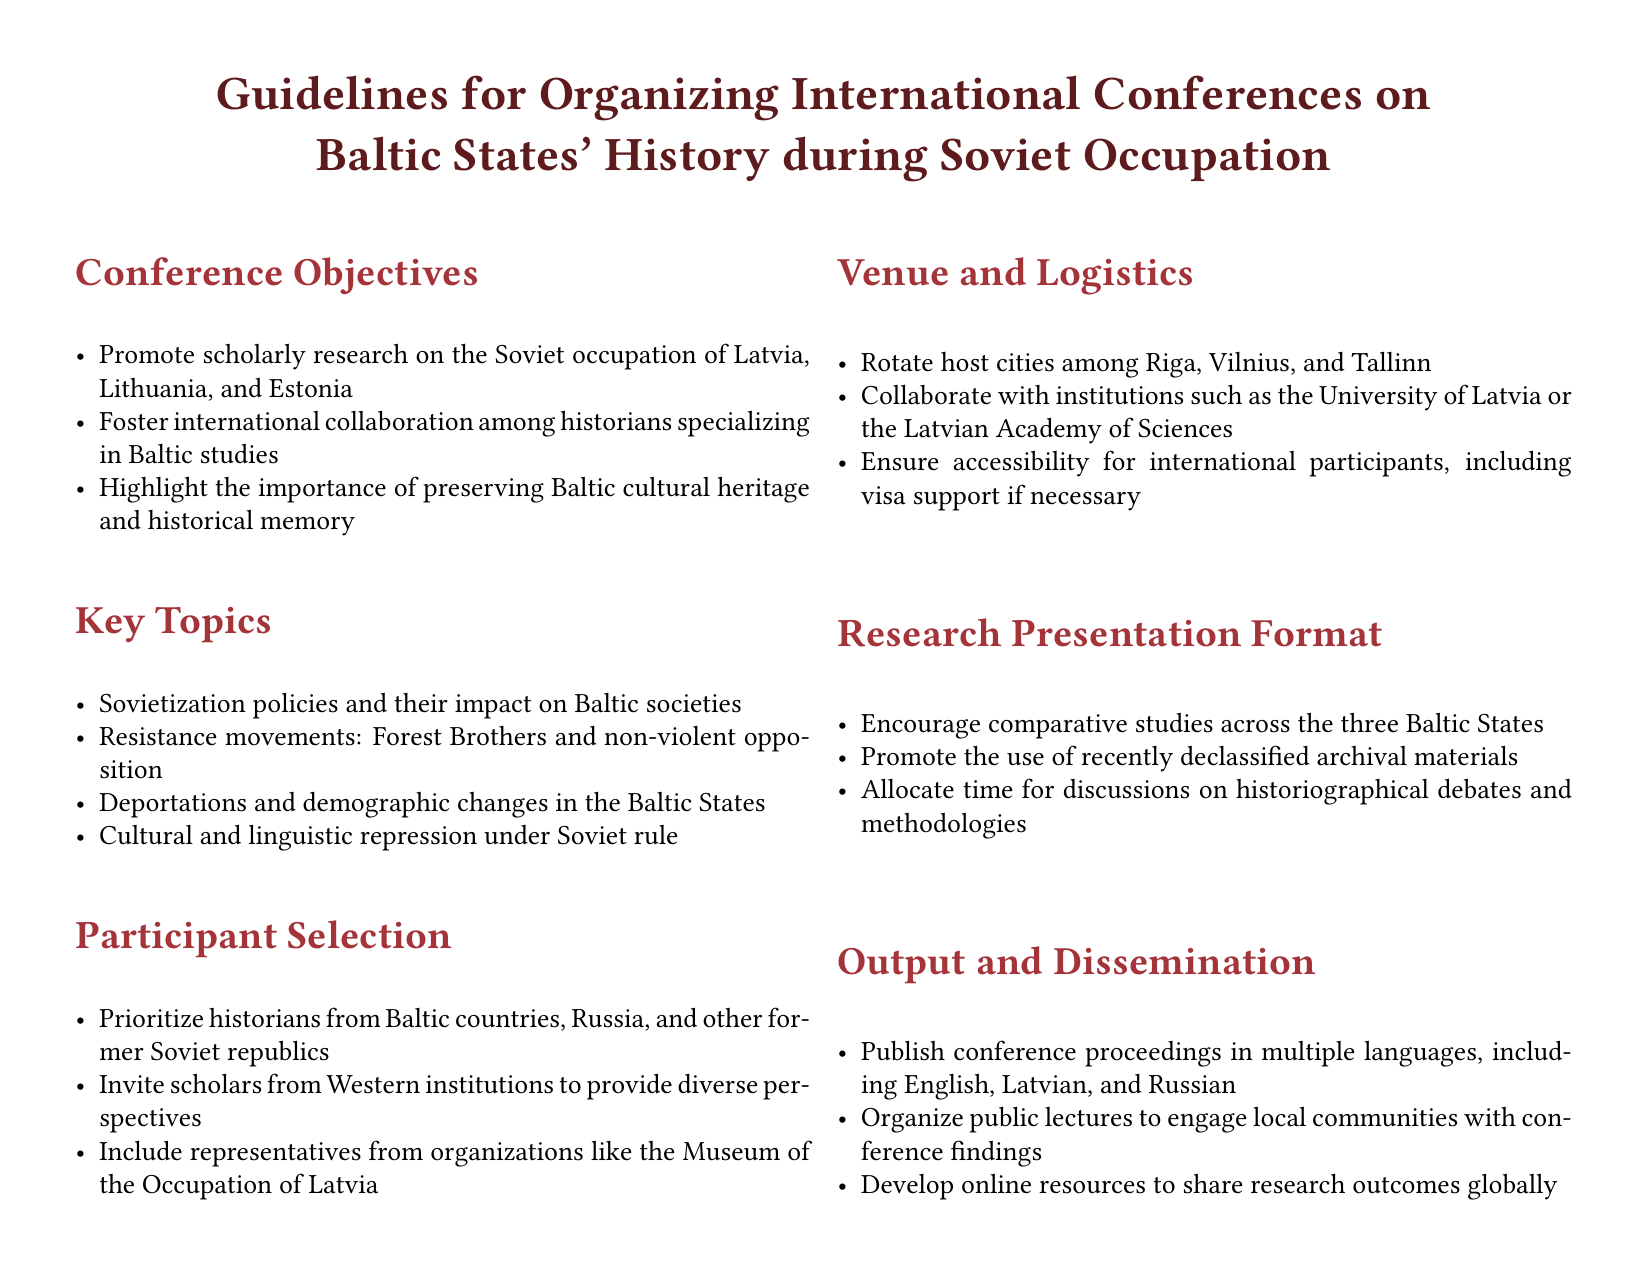What are the conference objectives? The conference objectives include promoting scholarly research, fostering international collaboration, and highlighting the importance of preserving cultural heritage.
Answer: Promote scholarly research on the Soviet occupation of Latvia, Lithuania, and Estonia, Foster international collaboration among historians specializing in Baltic studies, Highlight the importance of preserving Baltic cultural heritage and historical memory What is one key topic covered? The document lists several key topics related to the Soviet occupation; one of them focuses on Sovietization policies.
Answer: Sovietization policies and their impact on Baltic societies Who should be prioritized in participant selection? The participant selection section specifies who should be prioritized for invitations.
Answer: Historians from Baltic countries, Russia, and other former Soviet republics Which cities will host the conference? The document mentions that the host cities will rotate among three major cities in the Baltic States.
Answer: Riga, Vilnius, and Tallinn What languages will the conference proceedings be published in? The output and dissemination section states that the proceedings will be published in multiple languages.
Answer: English, Latvian, and Russian What type of studies are encouraged in research presentations? The guidelines suggest a specific focus for research presentations to enhance the conference discussions.
Answer: Comparative studies across the three Baltic States Which organizations are mentioned as potential participants? The participant selection section mentions specific organizations that may play a role in the conference.
Answer: Museum of the Occupation of Latvia What collaboration is suggested for venue and logistics? The venue and logistics section outlines potential collaborations for hosting the conference.
Answer: Institutions such as the University of Latvia or the Latvian Academy of Sciences What is a proposed method for community engagement? The output and dissemination section includes a suggested method to engage the local community related to conference findings.
Answer: Organize public lectures to engage local communities with conference findings 